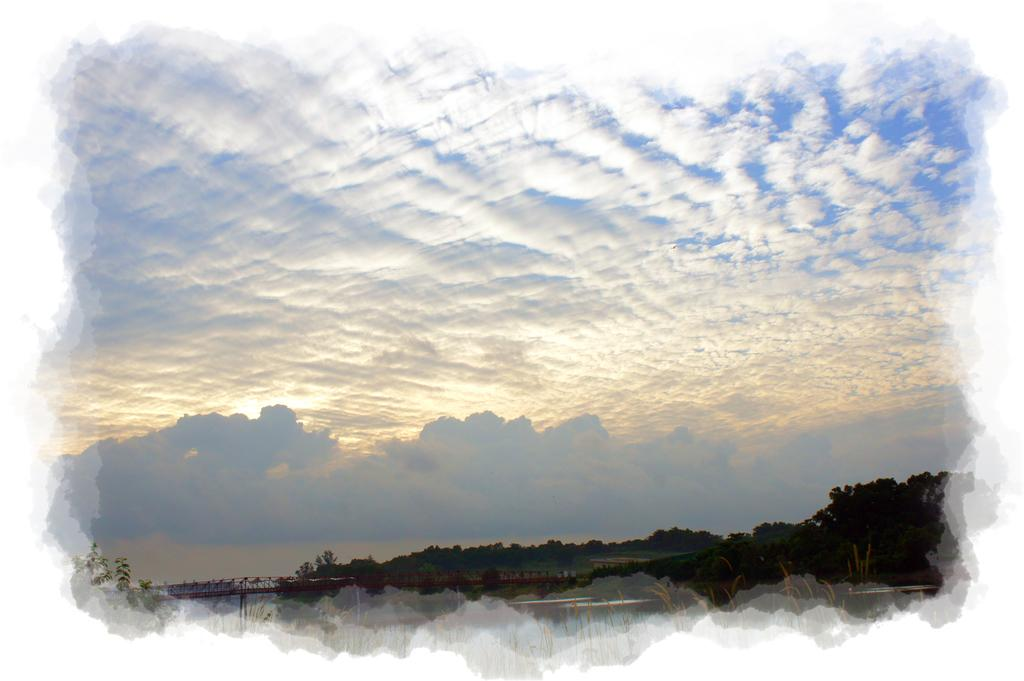What type of natural elements can be seen in the image? There are trees in the image. What structure is located on the left side of the image? There is a bridge on the left side of the image. What is visible in the image besides the trees and bridge? The sky is visible in the image. What colors can be seen in the sky? The sky has blue and white colors. What type of songs can be heard playing in the lunchroom in the image? There is no lunchroom or songs present in the image; it features trees, a bridge, and a sky with blue and white colors. What kind of loaf is being prepared on the bridge in the image? There is no loaf or preparation of any kind visible on the bridge in the image. 